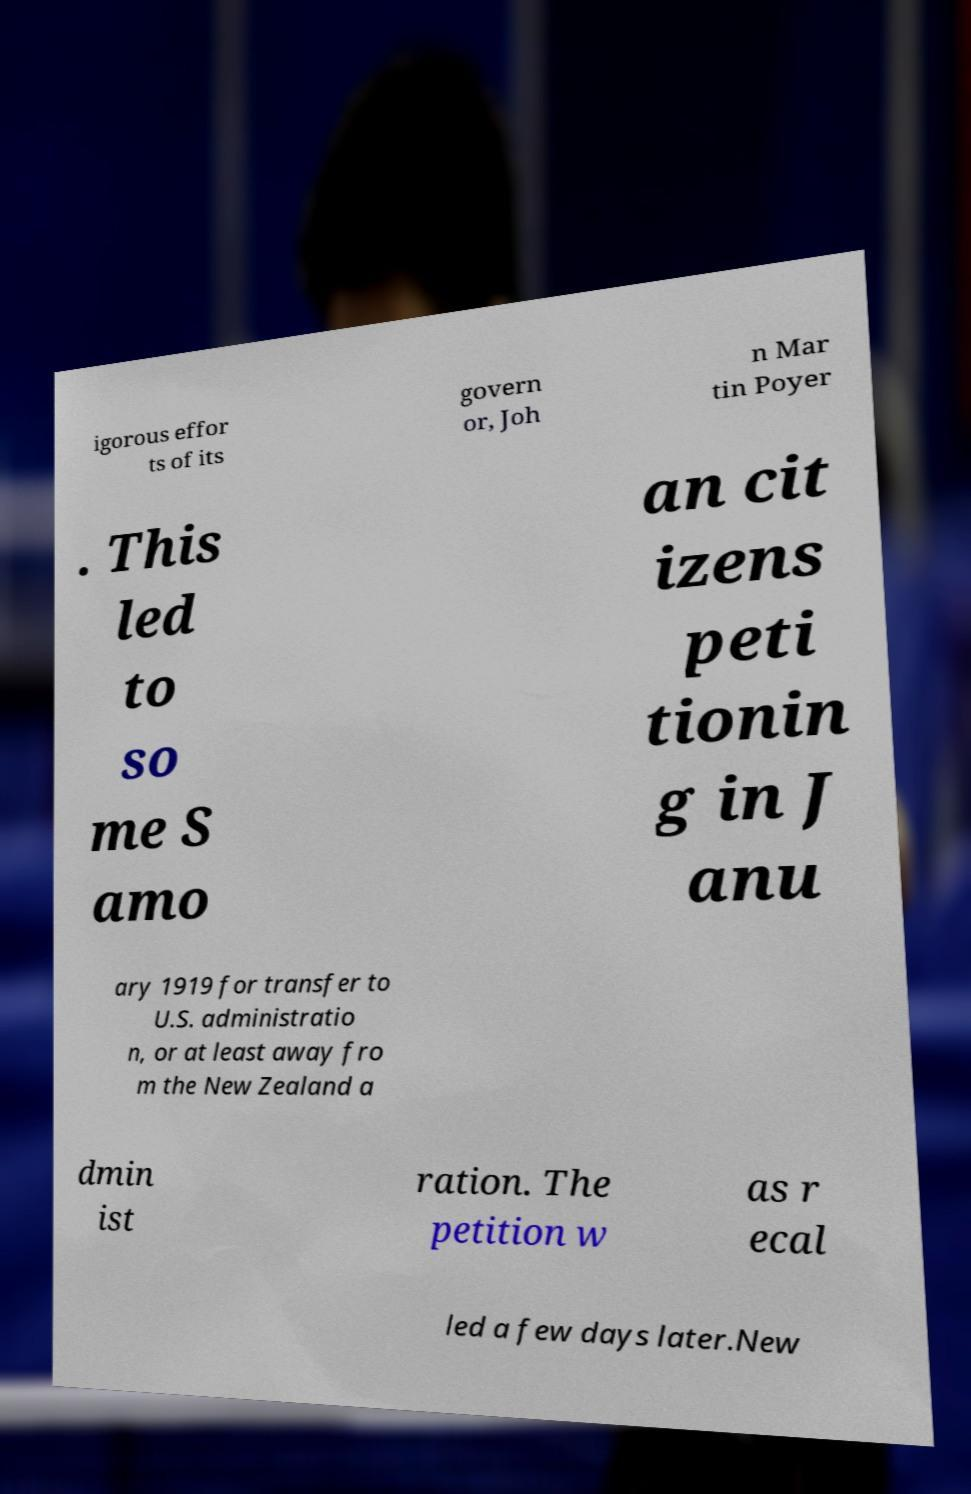Please read and relay the text visible in this image. What does it say? igorous effor ts of its govern or, Joh n Mar tin Poyer . This led to so me S amo an cit izens peti tionin g in J anu ary 1919 for transfer to U.S. administratio n, or at least away fro m the New Zealand a dmin ist ration. The petition w as r ecal led a few days later.New 